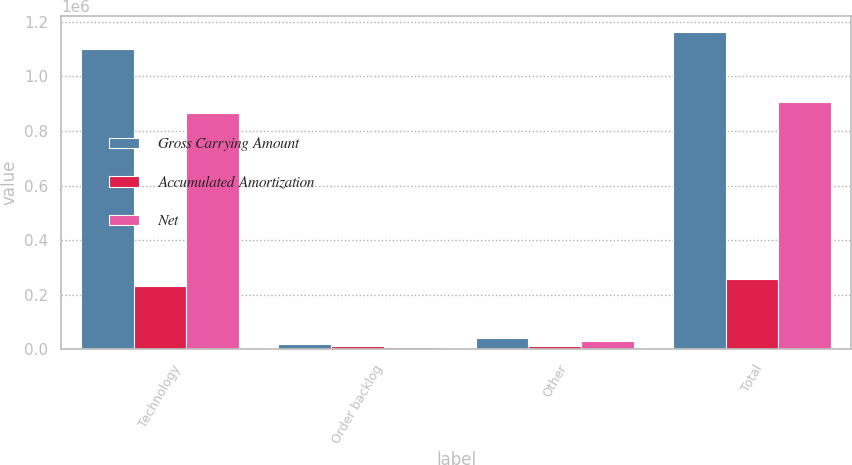Convert chart. <chart><loc_0><loc_0><loc_500><loc_500><stacked_bar_chart><ecel><fcel>Technology<fcel>Order backlog<fcel>Other<fcel>Total<nl><fcel>Gross Carrying Amount<fcel>1.10032e+06<fcel>19501<fcel>43229<fcel>1.16305e+06<nl><fcel>Accumulated Amortization<fcel>233434<fcel>10709<fcel>13557<fcel>257700<nl><fcel>Net<fcel>866883<fcel>8792<fcel>29672<fcel>905347<nl></chart> 